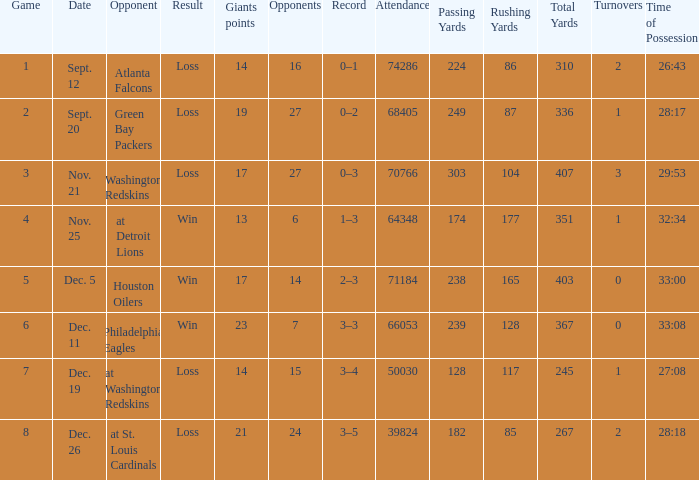What is the minimum number of opponents? 6.0. 